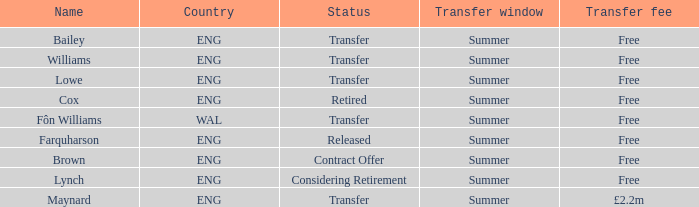What is the transfer window with a status of transfer from the country of Wal? Summer. 